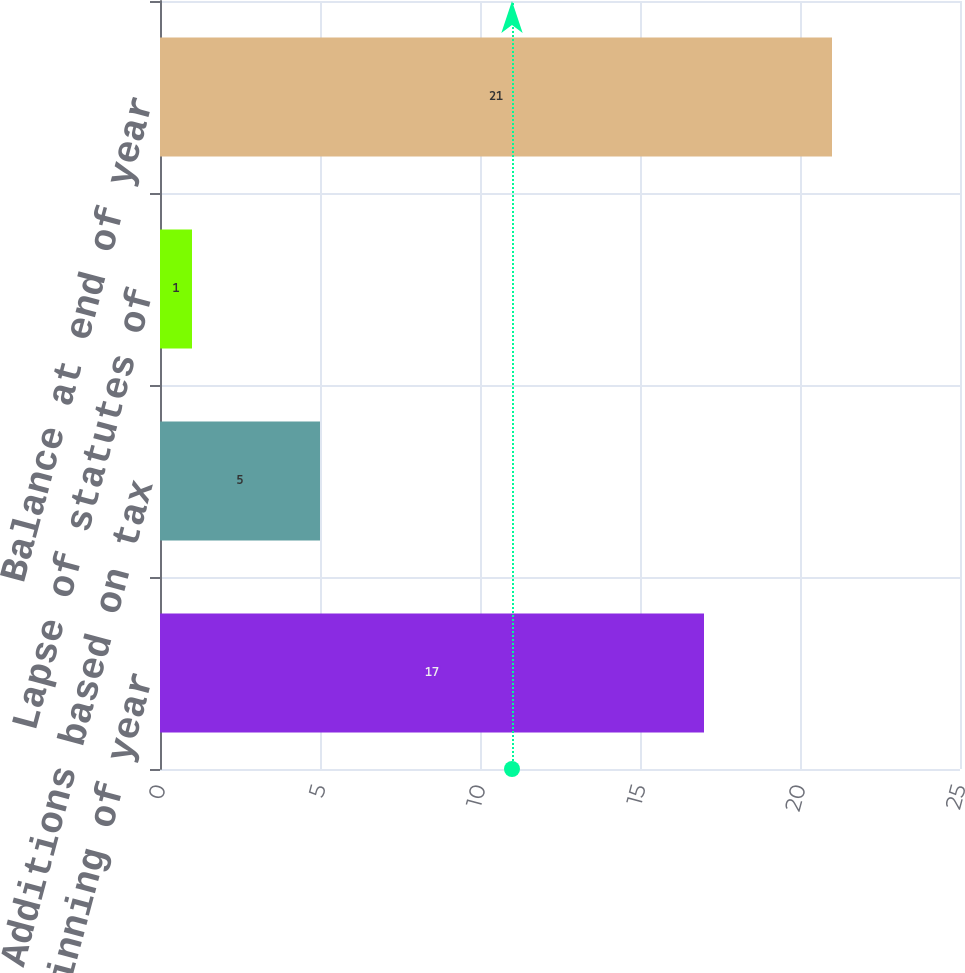<chart> <loc_0><loc_0><loc_500><loc_500><bar_chart><fcel>Balance at beginning of year<fcel>Additions based on tax<fcel>Lapse of statutes of<fcel>Balance at end of year<nl><fcel>17<fcel>5<fcel>1<fcel>21<nl></chart> 